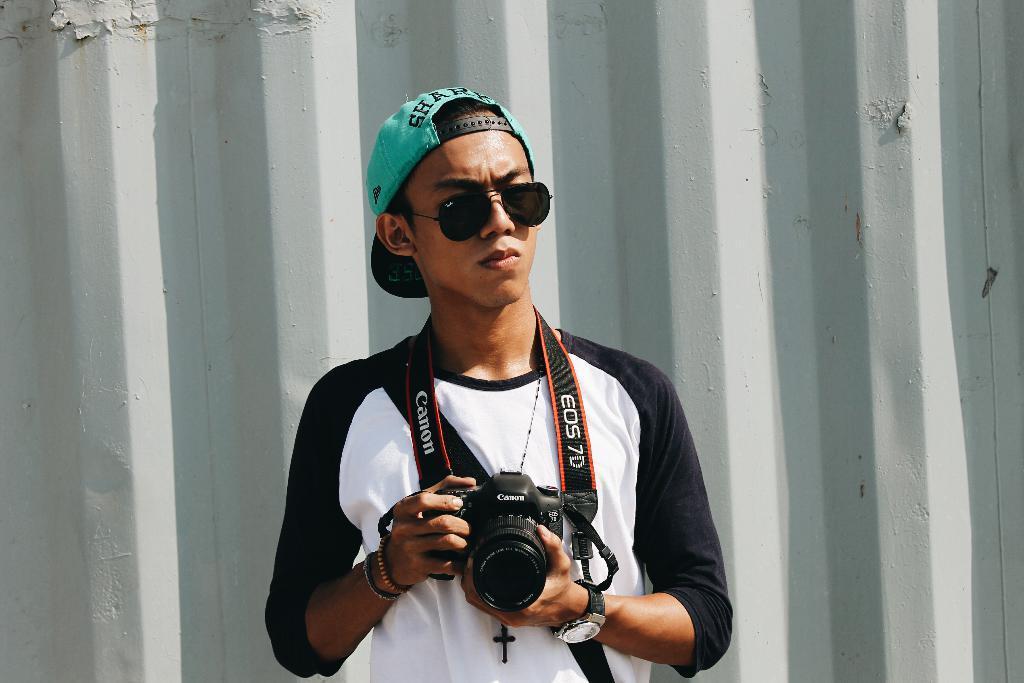Please provide a concise description of this image. This man wore black and white t-shirt, goggles, cap and holding a camera. 